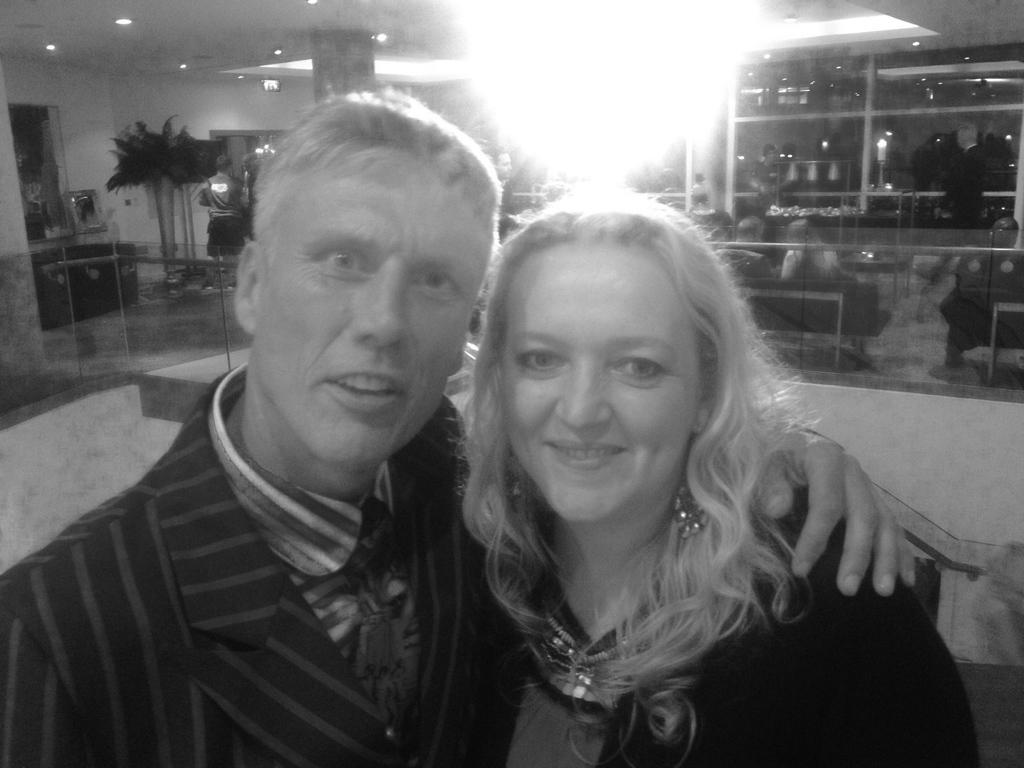How would you summarize this image in a sentence or two? This picture is in black and white. In front of the picture, we see the man in black jacket is standing beside the woman who is wearing a black jacket. She is smiling. Both of them are posing for the photo. Behind them, we see a table. In the background, we see a table and behind that, we see a rack in which glass bottles are placed. On the left side, we see flower pots and a wall on which photo frame is placed. This picture might be clicked in the restaurant. 